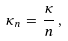Convert formula to latex. <formula><loc_0><loc_0><loc_500><loc_500>\kappa _ { n } = \frac { \kappa } { n } \, , \\</formula> 